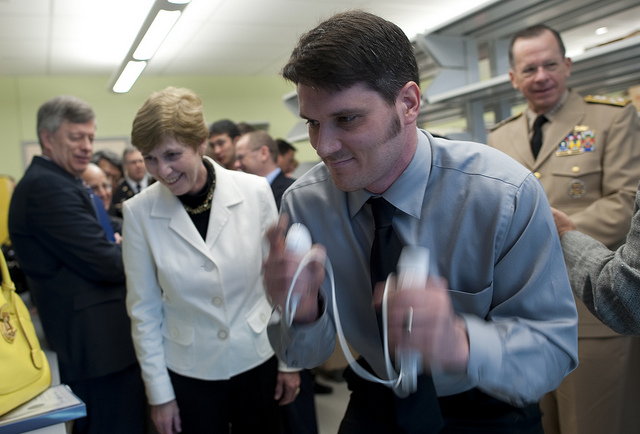How many sandwiches have white bread? It appears there has been a misunderstanding as the image does not show any sandwiches, thus making it impossible to count them or determine the type of bread they might have. 